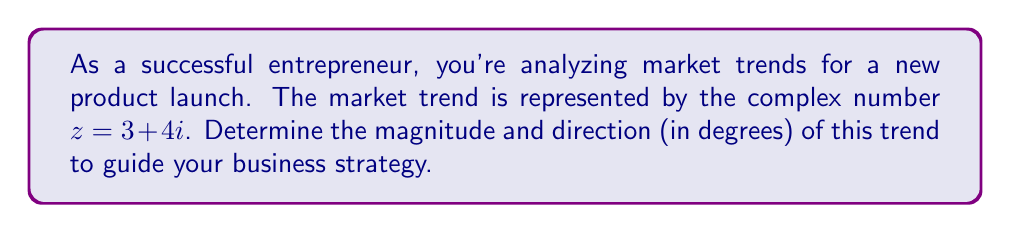Help me with this question. To find the magnitude and direction of the complex number $z = 3 + 4i$, we'll use the following steps:

1. Magnitude:
   The magnitude of a complex number $z = a + bi$ is given by $|z| = \sqrt{a^2 + b^2}$.
   
   For $z = 3 + 4i$:
   $$|z| = \sqrt{3^2 + 4^2} = \sqrt{9 + 16} = \sqrt{25} = 5$$

2. Direction:
   The direction (or argument) of a complex number is given by $\theta = \arctan(\frac{b}{a})$, where $a$ is the real part and $b$ is the imaginary part.
   
   For $z = 3 + 4i$:
   $$\theta = \arctan(\frac{4}{3})$$
   
   Using a calculator or trigonometric tables:
   $$\theta \approx 53.13^\circ$$

   Note: Since both the real and imaginary parts are positive, the angle is in the first quadrant, so no adjustment is needed.

Therefore, the market trend represented by $z = 3 + 4i$ has a magnitude of 5 and a direction of approximately 53.13°.
Answer: Magnitude: 5, Direction: 53.13° 